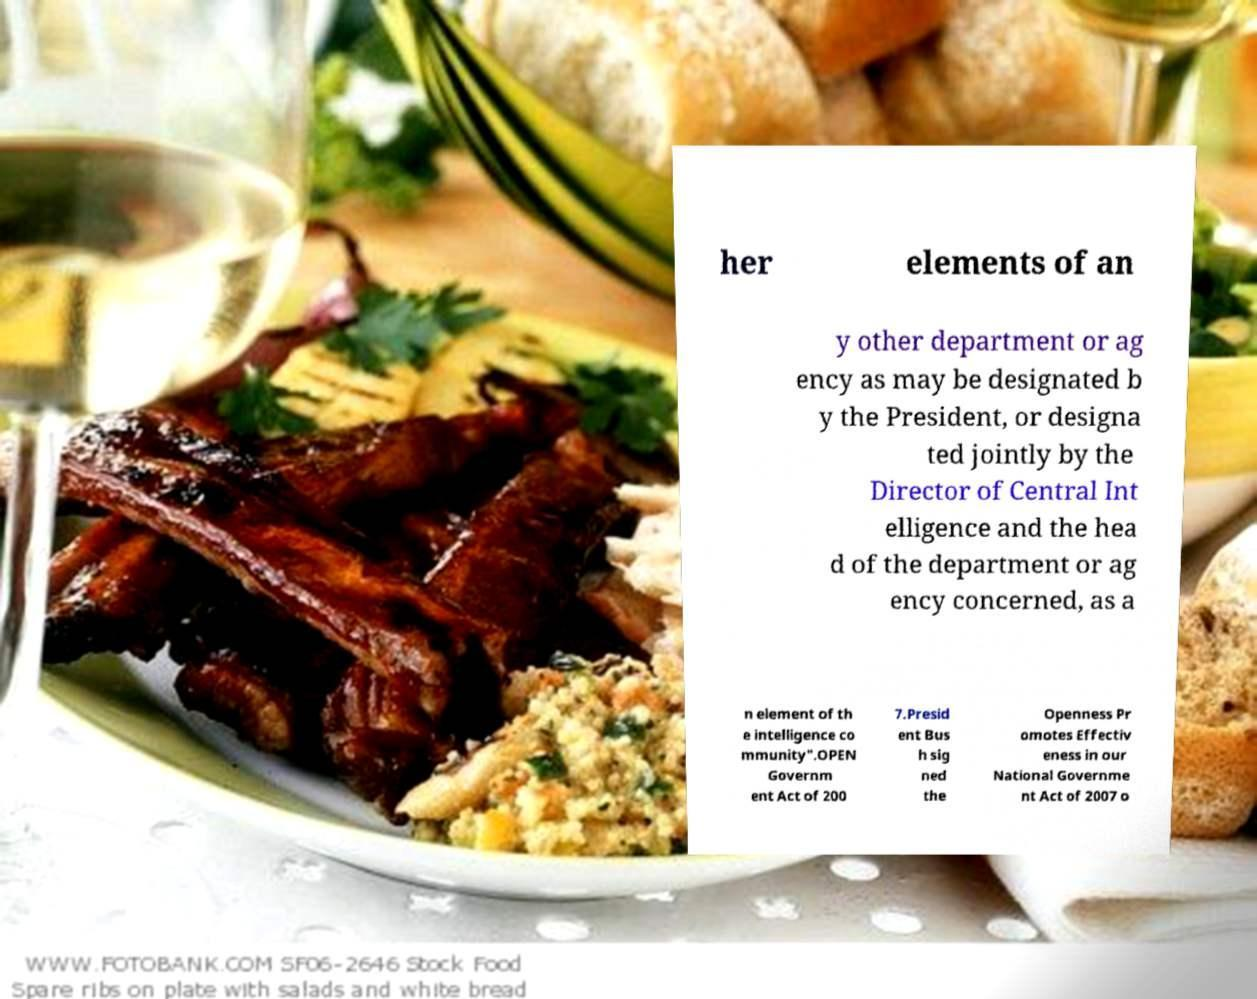Can you accurately transcribe the text from the provided image for me? her elements of an y other department or ag ency as may be designated b y the President, or designa ted jointly by the Director of Central Int elligence and the hea d of the department or ag ency concerned, as a n element of th e intelligence co mmunity".OPEN Governm ent Act of 200 7.Presid ent Bus h sig ned the Openness Pr omotes Effectiv eness in our National Governme nt Act of 2007 o 